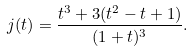Convert formula to latex. <formula><loc_0><loc_0><loc_500><loc_500>j ( t ) = \frac { t ^ { 3 } + 3 ( t ^ { 2 } - t + 1 ) } { ( 1 + t ) ^ { 3 } } .</formula> 